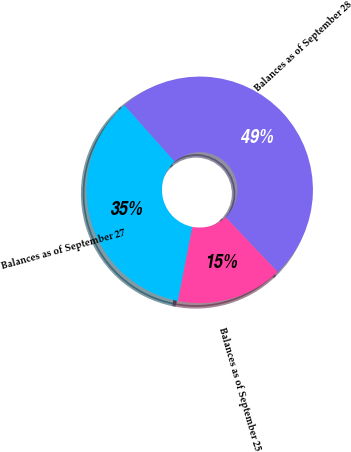<chart> <loc_0><loc_0><loc_500><loc_500><pie_chart><fcel>Balances as of September 28<fcel>Balances as of September 27<fcel>Balances as of September 25<nl><fcel>49.49%<fcel>35.35%<fcel>15.15%<nl></chart> 